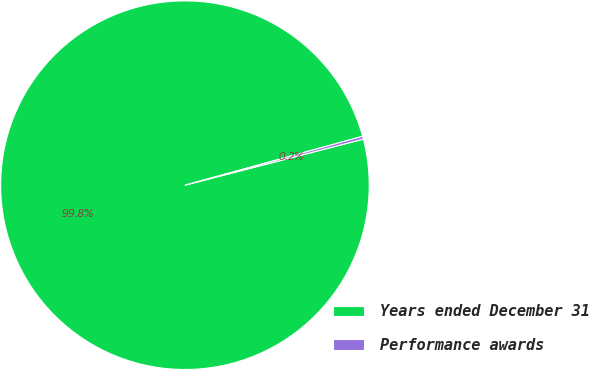Convert chart. <chart><loc_0><loc_0><loc_500><loc_500><pie_chart><fcel>Years ended December 31<fcel>Performance awards<nl><fcel>99.75%<fcel>0.25%<nl></chart> 